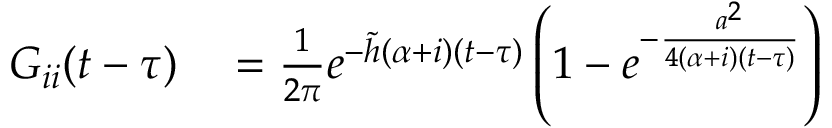<formula> <loc_0><loc_0><loc_500><loc_500>\begin{array} { r l } { G _ { i i } ( t - \tau ) } & = \frac { 1 } { 2 \pi } e ^ { - \tilde { h } ( \alpha + i ) ( t - \tau ) } \left ( 1 - e ^ { - \frac { a ^ { 2 } } { 4 ( \alpha + i ) ( t - \tau ) } } \right ) } \end{array}</formula> 